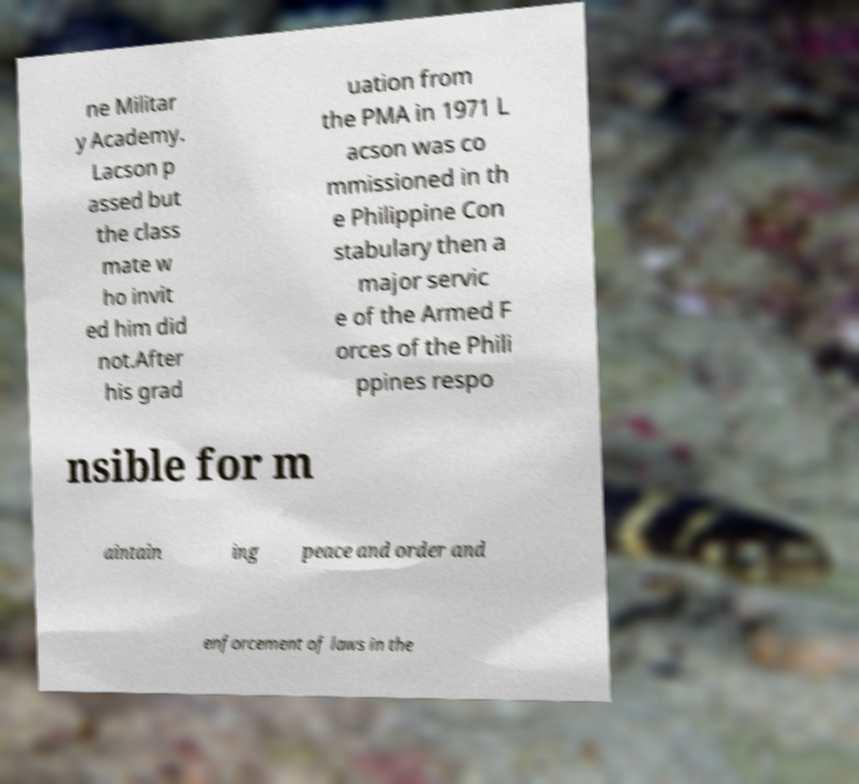Can you read and provide the text displayed in the image?This photo seems to have some interesting text. Can you extract and type it out for me? ne Militar y Academy. Lacson p assed but the class mate w ho invit ed him did not.After his grad uation from the PMA in 1971 L acson was co mmissioned in th e Philippine Con stabulary then a major servic e of the Armed F orces of the Phili ppines respo nsible for m aintain ing peace and order and enforcement of laws in the 